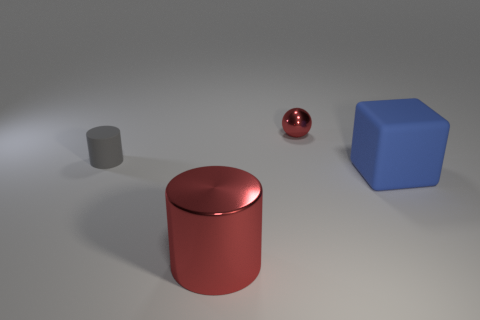The object that is both to the left of the blue cube and to the right of the large red metallic thing has what shape?
Offer a very short reply. Sphere. The rubber object to the right of the tiny cylinder is what color?
Your answer should be very brief. Blue. What size is the thing that is both in front of the tiny gray matte cylinder and to the right of the big shiny cylinder?
Your response must be concise. Large. Are the tiny cylinder and the big blue thing that is in front of the small metal sphere made of the same material?
Keep it short and to the point. Yes. What number of other red things are the same shape as the small metal thing?
Offer a terse response. 0. What material is the cylinder that is the same color as the tiny shiny object?
Give a very brief answer. Metal. What number of red shiny cylinders are there?
Your response must be concise. 1. Is the shape of the small matte object the same as the red object that is in front of the matte block?
Your response must be concise. Yes. What number of objects are large things or red things that are left of the blue matte cube?
Offer a terse response. 3. There is another gray object that is the same shape as the large metal thing; what is it made of?
Make the answer very short. Rubber. 